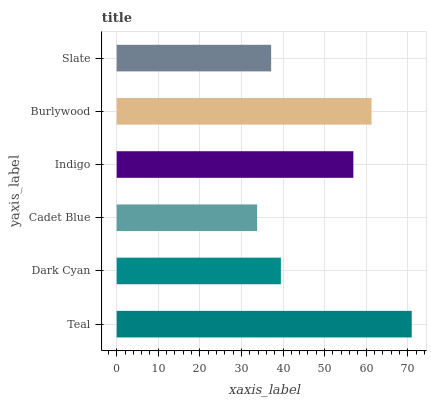Is Cadet Blue the minimum?
Answer yes or no. Yes. Is Teal the maximum?
Answer yes or no. Yes. Is Dark Cyan the minimum?
Answer yes or no. No. Is Dark Cyan the maximum?
Answer yes or no. No. Is Teal greater than Dark Cyan?
Answer yes or no. Yes. Is Dark Cyan less than Teal?
Answer yes or no. Yes. Is Dark Cyan greater than Teal?
Answer yes or no. No. Is Teal less than Dark Cyan?
Answer yes or no. No. Is Indigo the high median?
Answer yes or no. Yes. Is Dark Cyan the low median?
Answer yes or no. Yes. Is Slate the high median?
Answer yes or no. No. Is Slate the low median?
Answer yes or no. No. 